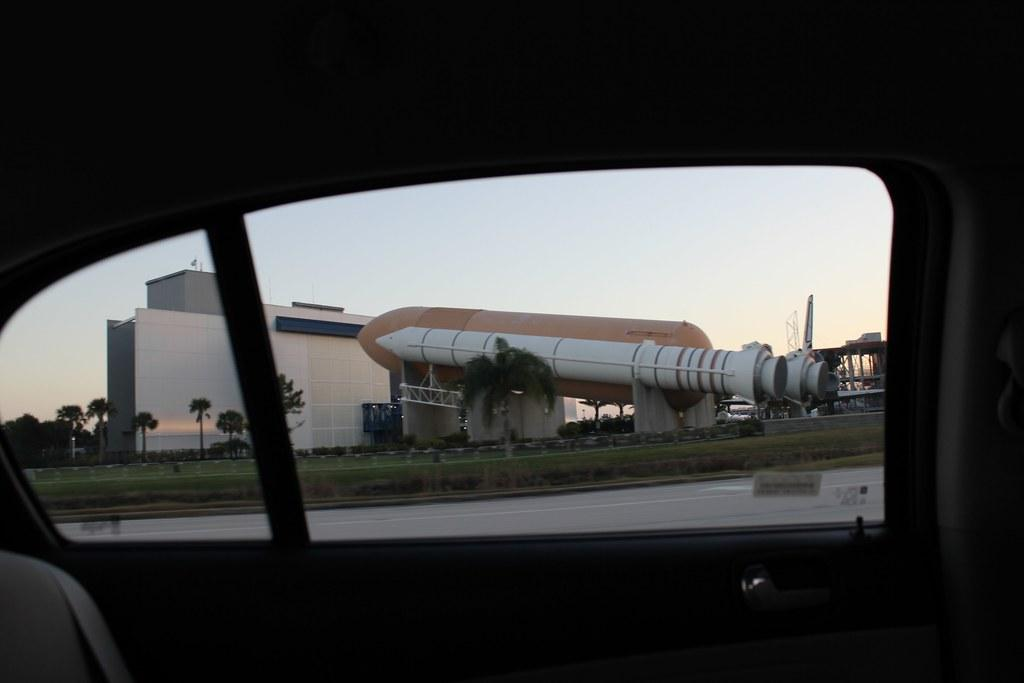What is the main subject of the image? There is a vehicle in the image. What can be seen in the background of the image? There are buildings, trees, and a model of a space rocket in the background of the image. Are there any other objects visible in the background? Yes, there are other objects in the background of the image. Can you see a twig being used as a design element in the image? There is no twig present in the image, and therefore no such design element can be observed. 